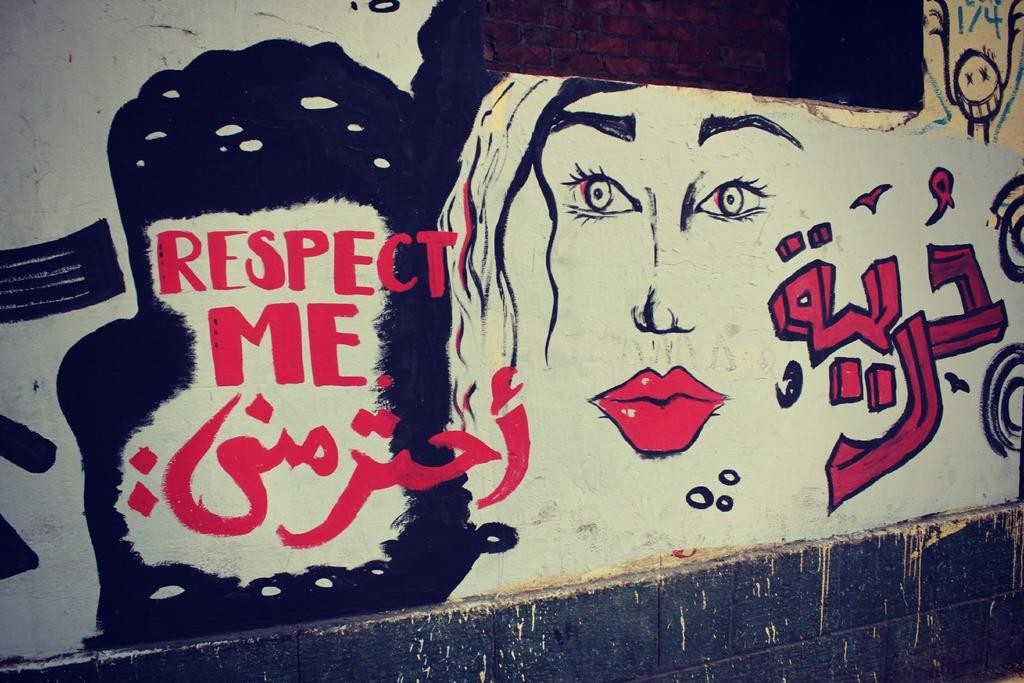What is the main subject of the image? There is a painting in the image. Can you describe any other elements in the image besides the painting? Yes, there is text on the wall in the image. What type of powder is being used to express anger in the image? There is no powder or expression of anger present in the image. 